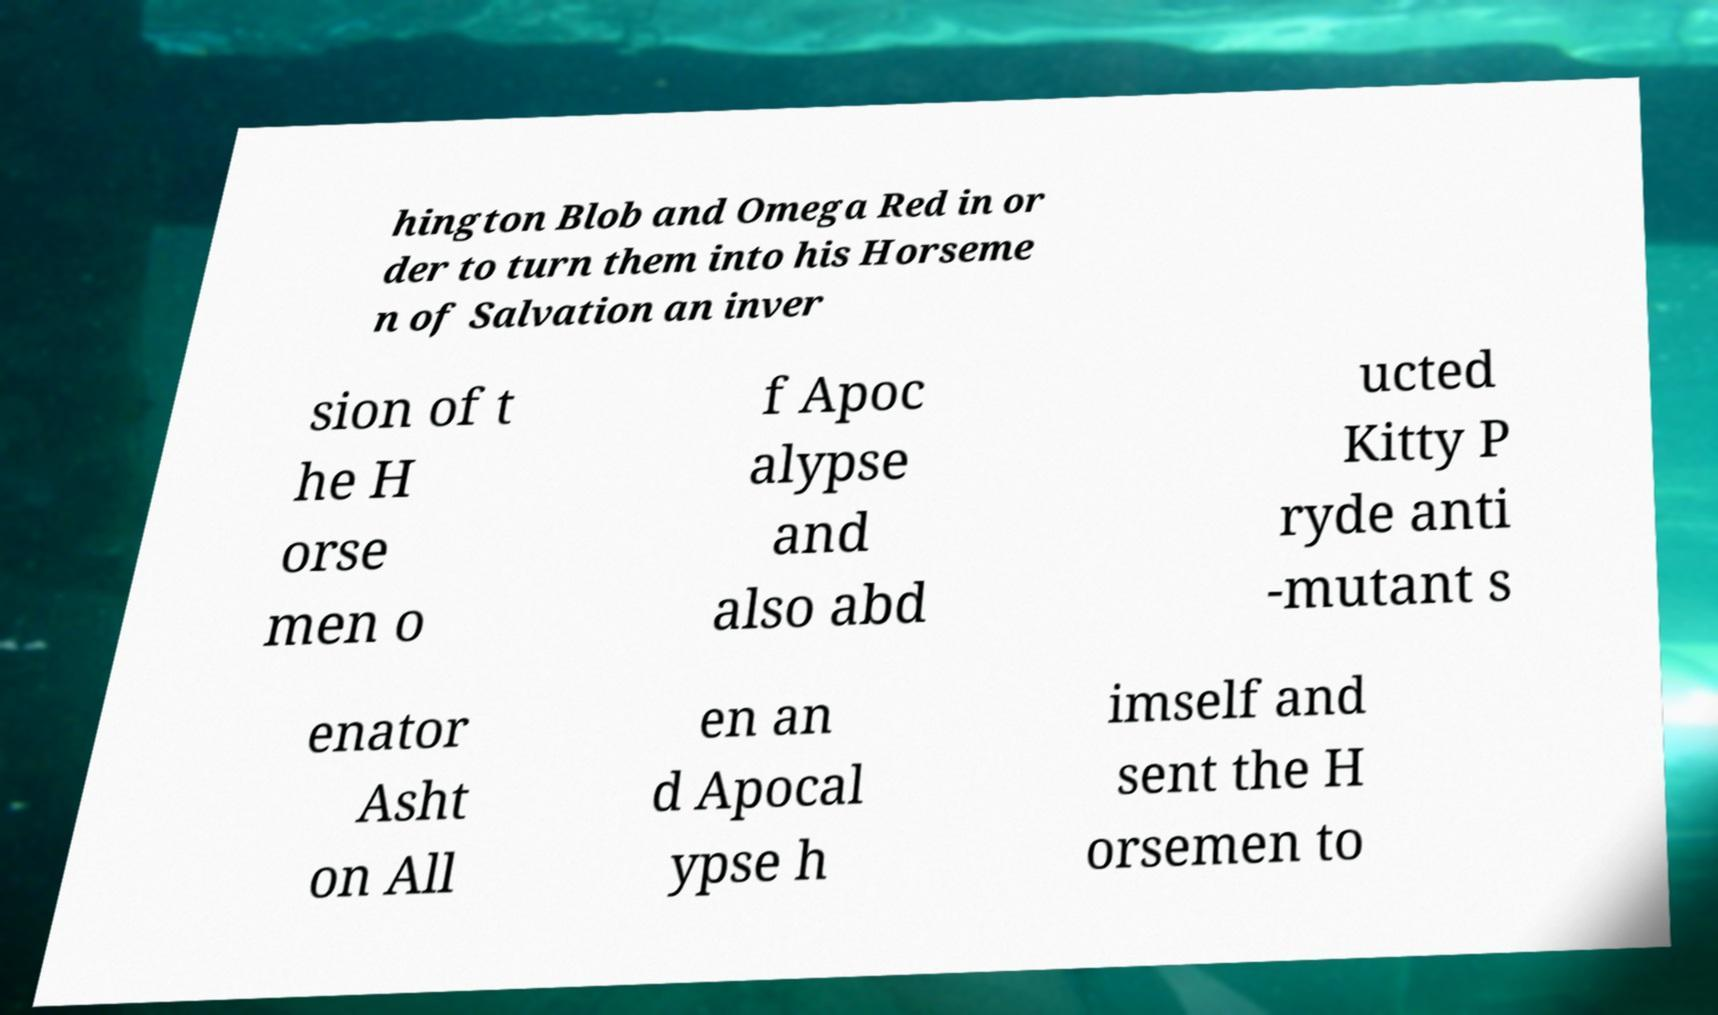What messages or text are displayed in this image? I need them in a readable, typed format. hington Blob and Omega Red in or der to turn them into his Horseme n of Salvation an inver sion of t he H orse men o f Apoc alypse and also abd ucted Kitty P ryde anti -mutant s enator Asht on All en an d Apocal ypse h imself and sent the H orsemen to 